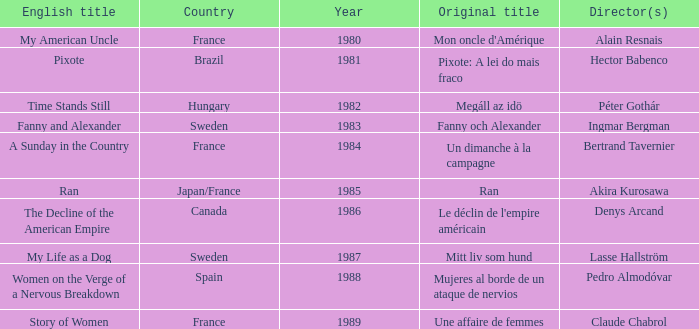What was the year of Megáll az Idö? 1982.0. 